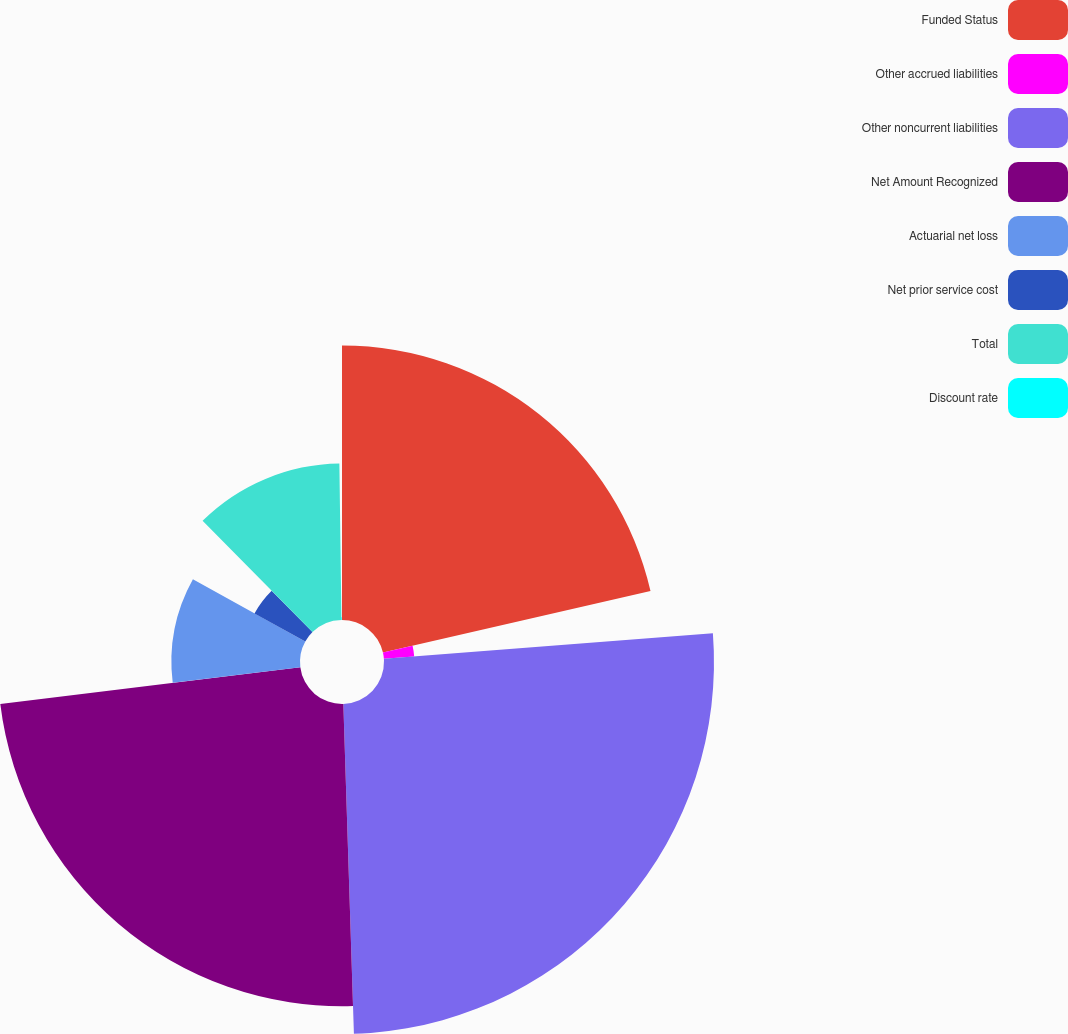Convert chart. <chart><loc_0><loc_0><loc_500><loc_500><pie_chart><fcel>Funded Status<fcel>Other accrued liabilities<fcel>Other noncurrent liabilities<fcel>Net Amount Recognized<fcel>Actuarial net loss<fcel>Net prior service cost<fcel>Total<fcel>Discount rate<nl><fcel>21.4%<fcel>2.37%<fcel>25.72%<fcel>23.56%<fcel>10.02%<fcel>4.53%<fcel>12.19%<fcel>0.21%<nl></chart> 